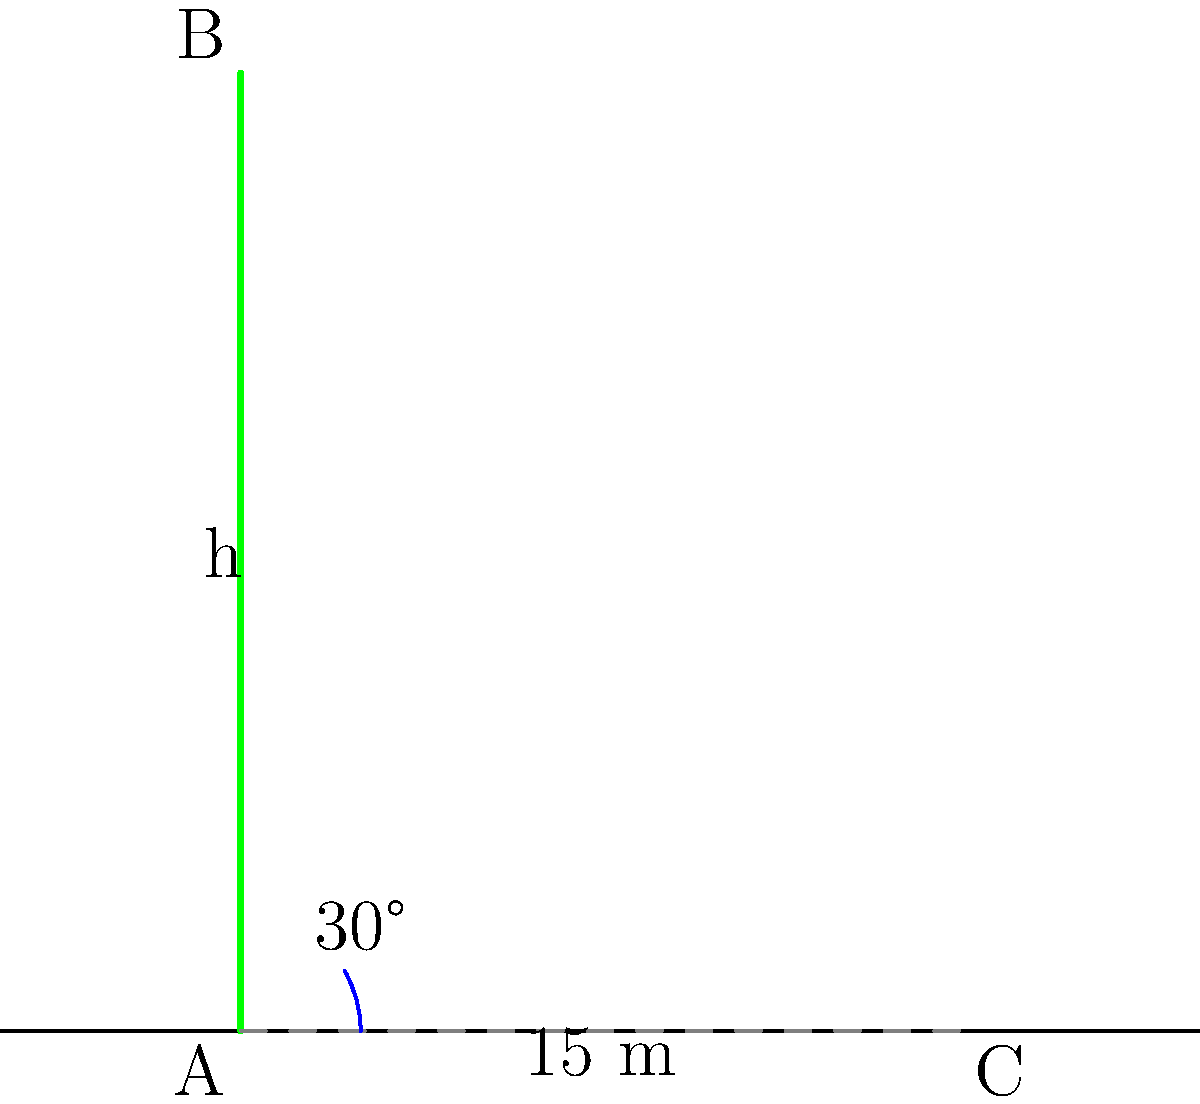As an experienced arborist, you're tasked with determining the height of an ancient oak tree in the neighborhood. Using the shadow method, you measure the tree's shadow to be 15 meters long when the sun's angle is 30° above the horizon. Calculate the height of the tree to the nearest tenth of a meter. Let's approach this step-by-step using trigonometry:

1) In the diagram, we have a right triangle formed by the tree (AB), its shadow (AC), and the sun's rays (BC).

2) We know:
   - The length of the shadow (AC) = 15 meters
   - The angle of the sun above the horizon = 30°

3) We need to find the height of the tree (AB), which we'll call h.

4) In this right triangle, we can use the tangent function:

   $\tan(\theta) = \frac{\text{opposite}}{\text{adjacent}} = \frac{h}{15}$

5) We know that $\tan(30°) = \frac{1}{\sqrt{3}} \approx 0.577$

6) So we can set up the equation:

   $0.577 = \frac{h}{15}$

7) To solve for h, multiply both sides by 15:

   $h = 15 * 0.577 = 8.655$ meters

8) Rounding to the nearest tenth:

   $h \approx 8.7$ meters
Answer: 8.7 meters 